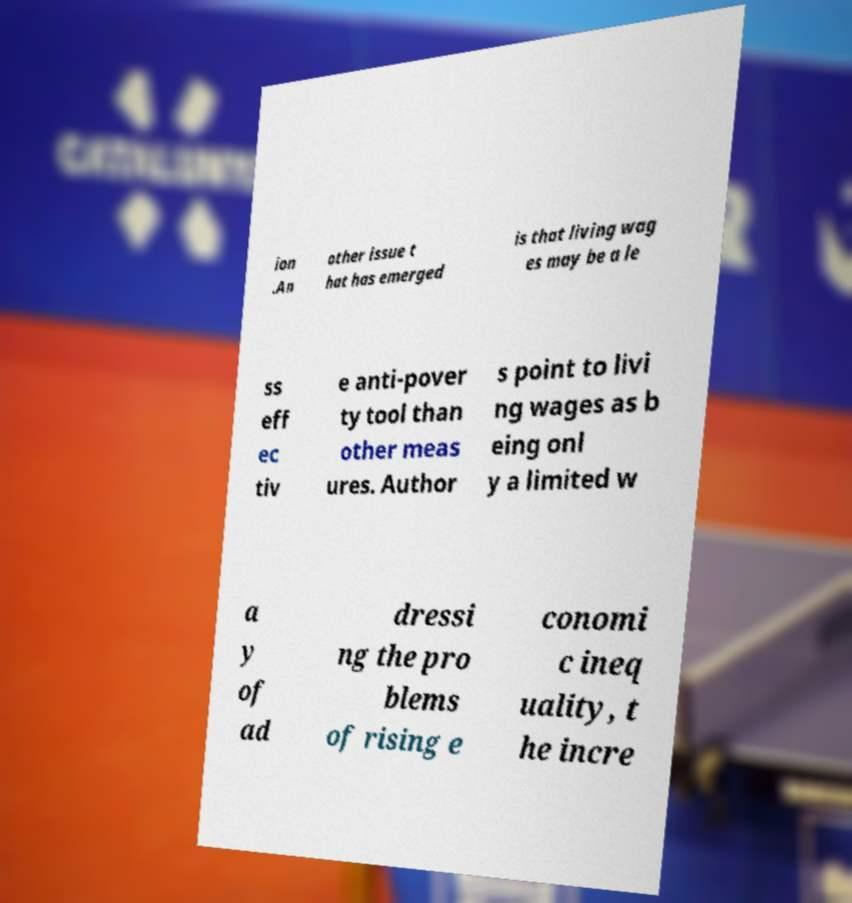I need the written content from this picture converted into text. Can you do that? ion .An other issue t hat has emerged is that living wag es may be a le ss eff ec tiv e anti-pover ty tool than other meas ures. Author s point to livi ng wages as b eing onl y a limited w a y of ad dressi ng the pro blems of rising e conomi c ineq uality, t he incre 